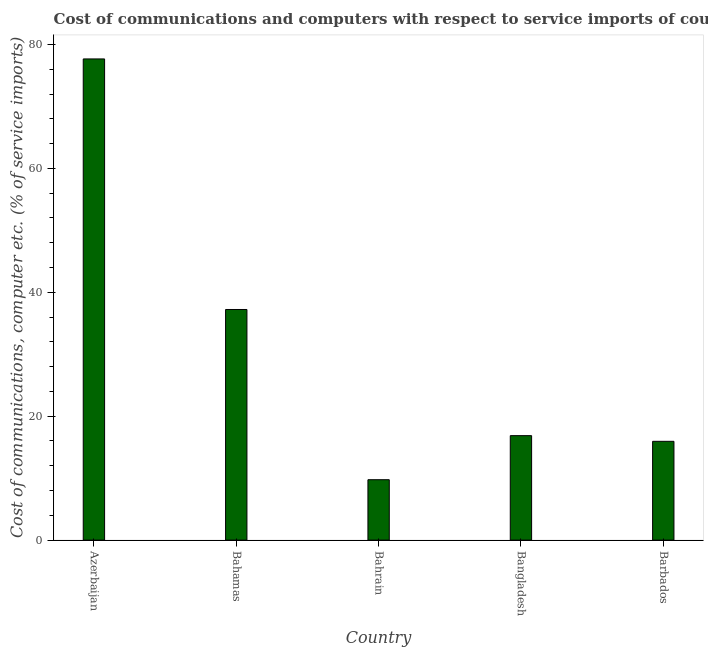What is the title of the graph?
Keep it short and to the point. Cost of communications and computers with respect to service imports of countries in 2005. What is the label or title of the X-axis?
Make the answer very short. Country. What is the label or title of the Y-axis?
Make the answer very short. Cost of communications, computer etc. (% of service imports). What is the cost of communications and computer in Barbados?
Provide a short and direct response. 15.94. Across all countries, what is the maximum cost of communications and computer?
Provide a succinct answer. 77.66. Across all countries, what is the minimum cost of communications and computer?
Ensure brevity in your answer.  9.75. In which country was the cost of communications and computer maximum?
Ensure brevity in your answer.  Azerbaijan. In which country was the cost of communications and computer minimum?
Make the answer very short. Bahrain. What is the sum of the cost of communications and computer?
Ensure brevity in your answer.  157.44. What is the difference between the cost of communications and computer in Azerbaijan and Bahamas?
Your answer should be very brief. 40.44. What is the average cost of communications and computer per country?
Give a very brief answer. 31.49. What is the median cost of communications and computer?
Make the answer very short. 16.86. What is the ratio of the cost of communications and computer in Azerbaijan to that in Bahamas?
Keep it short and to the point. 2.09. Is the difference between the cost of communications and computer in Bahamas and Bahrain greater than the difference between any two countries?
Your answer should be compact. No. What is the difference between the highest and the second highest cost of communications and computer?
Give a very brief answer. 40.44. What is the difference between the highest and the lowest cost of communications and computer?
Give a very brief answer. 67.92. In how many countries, is the cost of communications and computer greater than the average cost of communications and computer taken over all countries?
Your answer should be very brief. 2. Are all the bars in the graph horizontal?
Your response must be concise. No. How many countries are there in the graph?
Your answer should be compact. 5. What is the difference between two consecutive major ticks on the Y-axis?
Keep it short and to the point. 20. What is the Cost of communications, computer etc. (% of service imports) of Azerbaijan?
Offer a terse response. 77.66. What is the Cost of communications, computer etc. (% of service imports) of Bahamas?
Offer a terse response. 37.22. What is the Cost of communications, computer etc. (% of service imports) in Bahrain?
Offer a very short reply. 9.75. What is the Cost of communications, computer etc. (% of service imports) of Bangladesh?
Your answer should be very brief. 16.86. What is the Cost of communications, computer etc. (% of service imports) in Barbados?
Your answer should be very brief. 15.94. What is the difference between the Cost of communications, computer etc. (% of service imports) in Azerbaijan and Bahamas?
Give a very brief answer. 40.44. What is the difference between the Cost of communications, computer etc. (% of service imports) in Azerbaijan and Bahrain?
Offer a very short reply. 67.92. What is the difference between the Cost of communications, computer etc. (% of service imports) in Azerbaijan and Bangladesh?
Offer a terse response. 60.8. What is the difference between the Cost of communications, computer etc. (% of service imports) in Azerbaijan and Barbados?
Your response must be concise. 61.72. What is the difference between the Cost of communications, computer etc. (% of service imports) in Bahamas and Bahrain?
Make the answer very short. 27.48. What is the difference between the Cost of communications, computer etc. (% of service imports) in Bahamas and Bangladesh?
Give a very brief answer. 20.36. What is the difference between the Cost of communications, computer etc. (% of service imports) in Bahamas and Barbados?
Your answer should be compact. 21.28. What is the difference between the Cost of communications, computer etc. (% of service imports) in Bahrain and Bangladesh?
Your response must be concise. -7.11. What is the difference between the Cost of communications, computer etc. (% of service imports) in Bahrain and Barbados?
Your response must be concise. -6.2. What is the difference between the Cost of communications, computer etc. (% of service imports) in Bangladesh and Barbados?
Make the answer very short. 0.92. What is the ratio of the Cost of communications, computer etc. (% of service imports) in Azerbaijan to that in Bahamas?
Your answer should be very brief. 2.09. What is the ratio of the Cost of communications, computer etc. (% of service imports) in Azerbaijan to that in Bahrain?
Provide a succinct answer. 7.97. What is the ratio of the Cost of communications, computer etc. (% of service imports) in Azerbaijan to that in Bangladesh?
Give a very brief answer. 4.61. What is the ratio of the Cost of communications, computer etc. (% of service imports) in Azerbaijan to that in Barbados?
Ensure brevity in your answer.  4.87. What is the ratio of the Cost of communications, computer etc. (% of service imports) in Bahamas to that in Bahrain?
Give a very brief answer. 3.82. What is the ratio of the Cost of communications, computer etc. (% of service imports) in Bahamas to that in Bangladesh?
Ensure brevity in your answer.  2.21. What is the ratio of the Cost of communications, computer etc. (% of service imports) in Bahamas to that in Barbados?
Give a very brief answer. 2.33. What is the ratio of the Cost of communications, computer etc. (% of service imports) in Bahrain to that in Bangladesh?
Your response must be concise. 0.58. What is the ratio of the Cost of communications, computer etc. (% of service imports) in Bahrain to that in Barbados?
Ensure brevity in your answer.  0.61. What is the ratio of the Cost of communications, computer etc. (% of service imports) in Bangladesh to that in Barbados?
Offer a terse response. 1.06. 